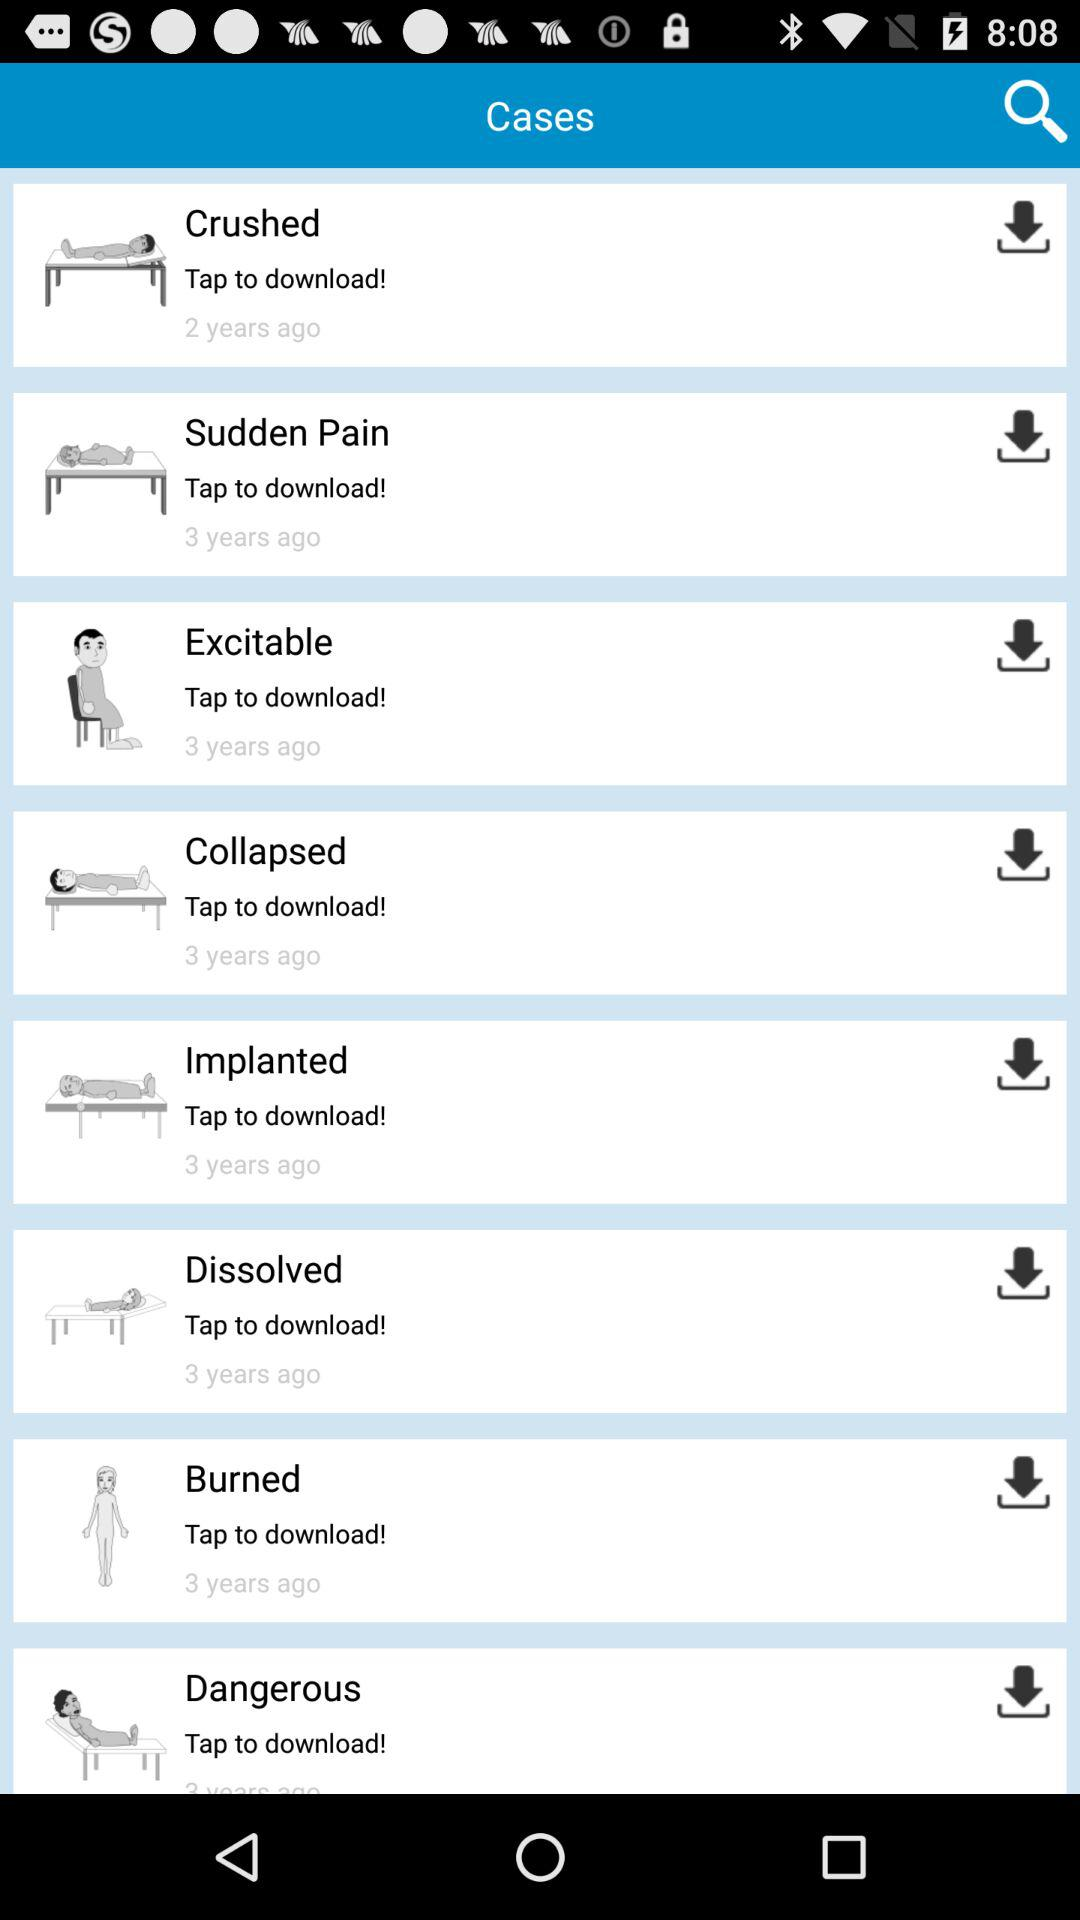What is the time duration of the published case "Burned"? The case "Burned" was published 3 years ago. 